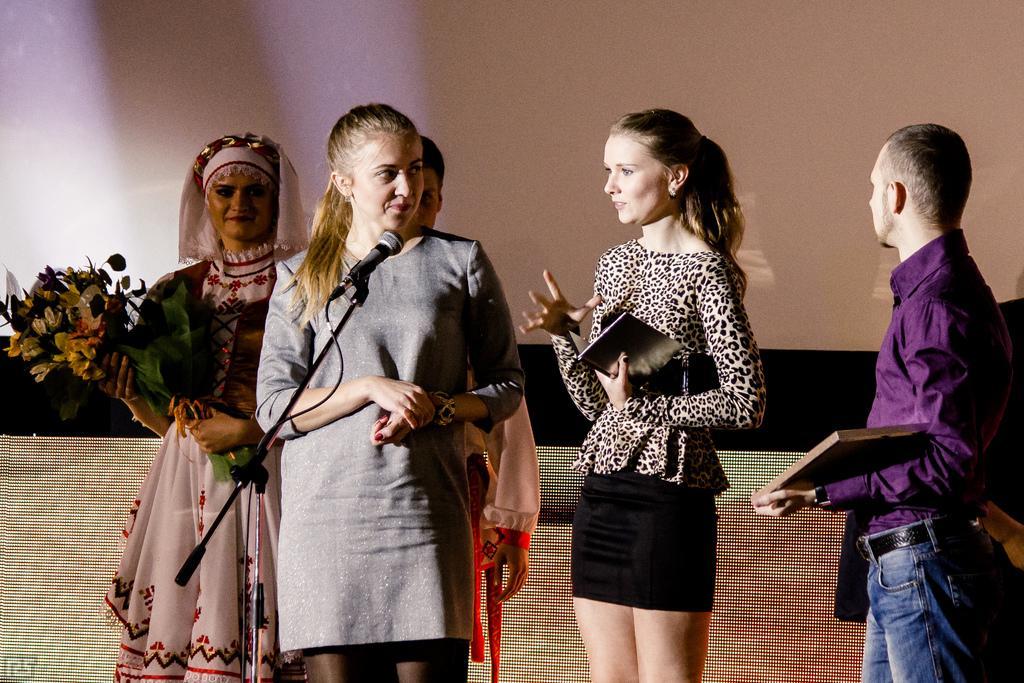How would you summarize this image in a sentence or two? In the foreground I can see five persons are standing on the stage in front of a mike and holding books and a bouquet. In the background I can see a wall. This image is taken may be in a hall. 